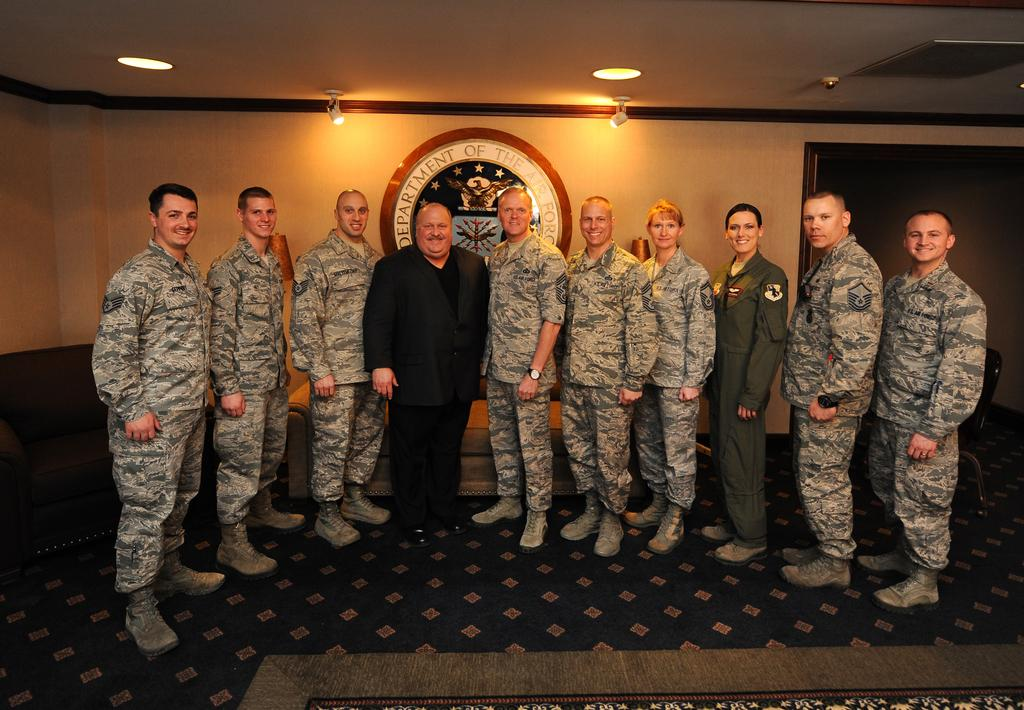What can be seen in the image regarding human presence? There are people standing in the image. Where are the people standing? The people are standing on the floor. What is present on the ground in the image? There is a floor mat on the ground. What can be seen on the wall in the background? There is a logo on the wall in the background. What is visible at the top of the image? There are lightings on the top of the image. What type of desk is being used by the authority in the image? There is no desk or authority figure present in the image. 